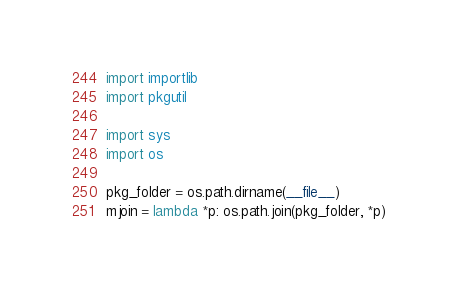Convert code to text. <code><loc_0><loc_0><loc_500><loc_500><_Python_>import importlib
import pkgutil

import sys
import os

pkg_folder = os.path.dirname(__file__)
mjoin = lambda *p: os.path.join(pkg_folder, *p)

</code> 